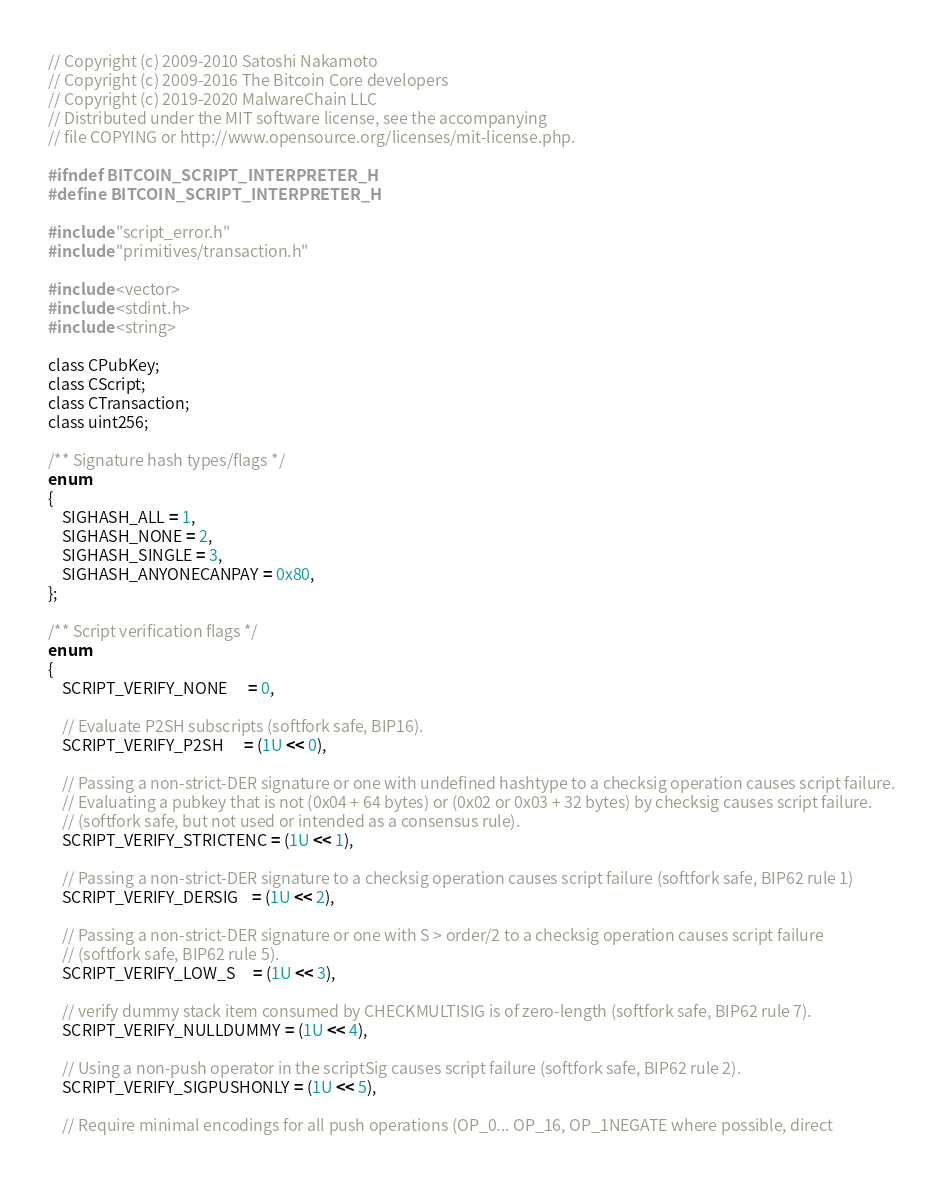Convert code to text. <code><loc_0><loc_0><loc_500><loc_500><_C_>// Copyright (c) 2009-2010 Satoshi Nakamoto
// Copyright (c) 2009-2016 The Bitcoin Core developers
// Copyright (c) 2019-2020 MalwareChain LLC
// Distributed under the MIT software license, see the accompanying
// file COPYING or http://www.opensource.org/licenses/mit-license.php.

#ifndef BITCOIN_SCRIPT_INTERPRETER_H
#define BITCOIN_SCRIPT_INTERPRETER_H

#include "script_error.h"
#include "primitives/transaction.h"

#include <vector>
#include <stdint.h>
#include <string>

class CPubKey;
class CScript;
class CTransaction;
class uint256;

/** Signature hash types/flags */
enum
{
    SIGHASH_ALL = 1,
    SIGHASH_NONE = 2,
    SIGHASH_SINGLE = 3,
    SIGHASH_ANYONECANPAY = 0x80,
};

/** Script verification flags */
enum
{
    SCRIPT_VERIFY_NONE      = 0,

    // Evaluate P2SH subscripts (softfork safe, BIP16).
    SCRIPT_VERIFY_P2SH      = (1U << 0),

    // Passing a non-strict-DER signature or one with undefined hashtype to a checksig operation causes script failure.
    // Evaluating a pubkey that is not (0x04 + 64 bytes) or (0x02 or 0x03 + 32 bytes) by checksig causes script failure.
    // (softfork safe, but not used or intended as a consensus rule).
    SCRIPT_VERIFY_STRICTENC = (1U << 1),

    // Passing a non-strict-DER signature to a checksig operation causes script failure (softfork safe, BIP62 rule 1)
    SCRIPT_VERIFY_DERSIG    = (1U << 2),

    // Passing a non-strict-DER signature or one with S > order/2 to a checksig operation causes script failure
    // (softfork safe, BIP62 rule 5).
    SCRIPT_VERIFY_LOW_S     = (1U << 3),

    // verify dummy stack item consumed by CHECKMULTISIG is of zero-length (softfork safe, BIP62 rule 7).
    SCRIPT_VERIFY_NULLDUMMY = (1U << 4),

    // Using a non-push operator in the scriptSig causes script failure (softfork safe, BIP62 rule 2).
    SCRIPT_VERIFY_SIGPUSHONLY = (1U << 5),

    // Require minimal encodings for all push operations (OP_0... OP_16, OP_1NEGATE where possible, direct</code> 